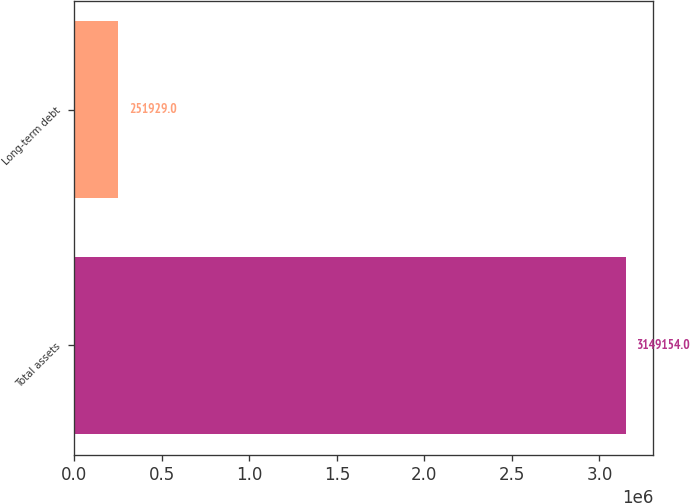<chart> <loc_0><loc_0><loc_500><loc_500><bar_chart><fcel>Total assets<fcel>Long-term debt<nl><fcel>3.14915e+06<fcel>251929<nl></chart> 